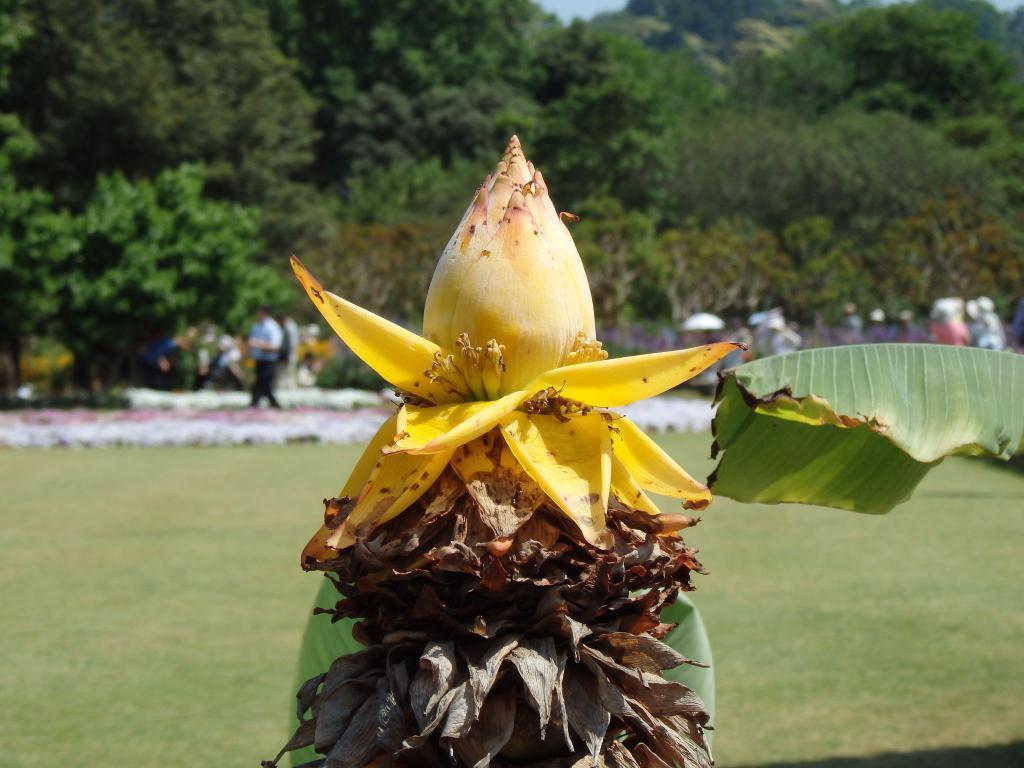Can you describe this image briefly? In this image we can see a flower of a banana tree. We can also see some dried leaves. On the right side we can see a green banana leaf. On the backside we can see some people walking. We can also see grass, group of trees and the sky. 